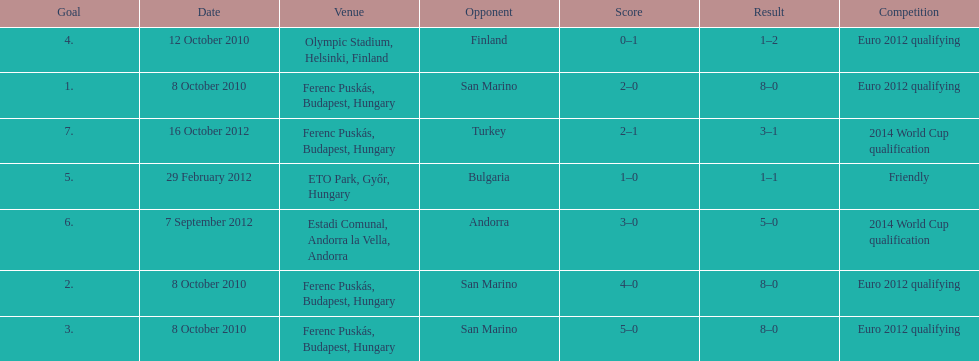Can you parse all the data within this table? {'header': ['Goal', 'Date', 'Venue', 'Opponent', 'Score', 'Result', 'Competition'], 'rows': [['4.', '12 October 2010', 'Olympic Stadium, Helsinki, Finland', 'Finland', '0–1', '1–2', 'Euro 2012 qualifying'], ['1.', '8 October 2010', 'Ferenc Puskás, Budapest, Hungary', 'San Marino', '2–0', '8–0', 'Euro 2012 qualifying'], ['7.', '16 October 2012', 'Ferenc Puskás, Budapest, Hungary', 'Turkey', '2–1', '3–1', '2014 World Cup qualification'], ['5.', '29 February 2012', 'ETO Park, Győr, Hungary', 'Bulgaria', '1–0', '1–1', 'Friendly'], ['6.', '7 September 2012', 'Estadi Comunal, Andorra la Vella, Andorra', 'Andorra', '3–0', '5–0', '2014 World Cup qualification'], ['2.', '8 October 2010', 'Ferenc Puskás, Budapest, Hungary', 'San Marino', '4–0', '8–0', 'Euro 2012 qualifying'], ['3.', '8 October 2010', 'Ferenc Puskás, Budapest, Hungary', 'San Marino', '5–0', '8–0', 'Euro 2012 qualifying']]} What is the total number of international goals ádám szalai has made? 7. 